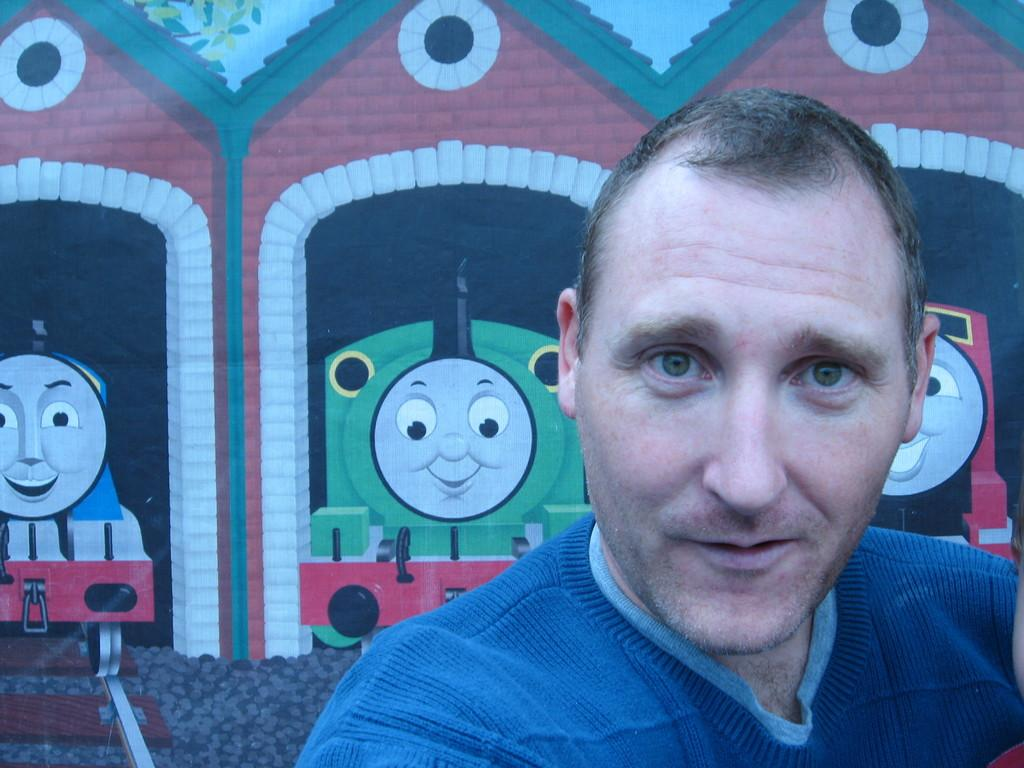Who is the main subject in the picture? There is an image of a man in the picture. What can be seen in the background of the picture? There is a wall in the background of the picture. What is depicted on the wall? The wall has a painting of train engines on it. What sign can be seen on the train engine in the painting? There is no sign visible on the train engine in the painting; it is a painting of train engines, not a photograph of actual train engines. 